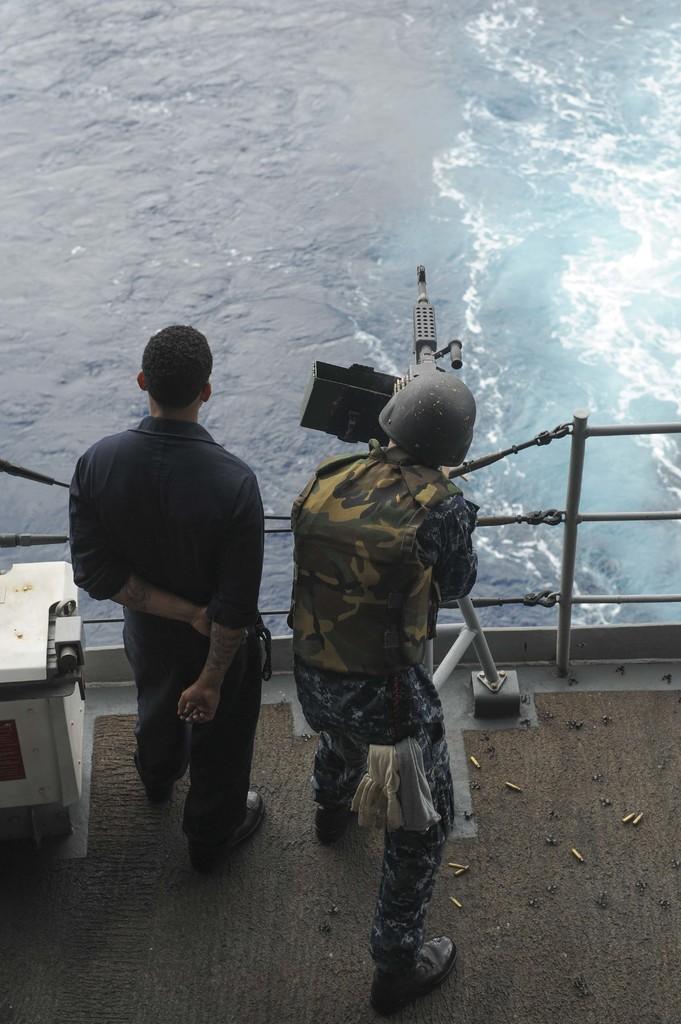Could you give a brief overview of what you see in this image? In this picture I can see the water. I can see a person holding the machine gun on the right side. I can see a person standing on the left side. 